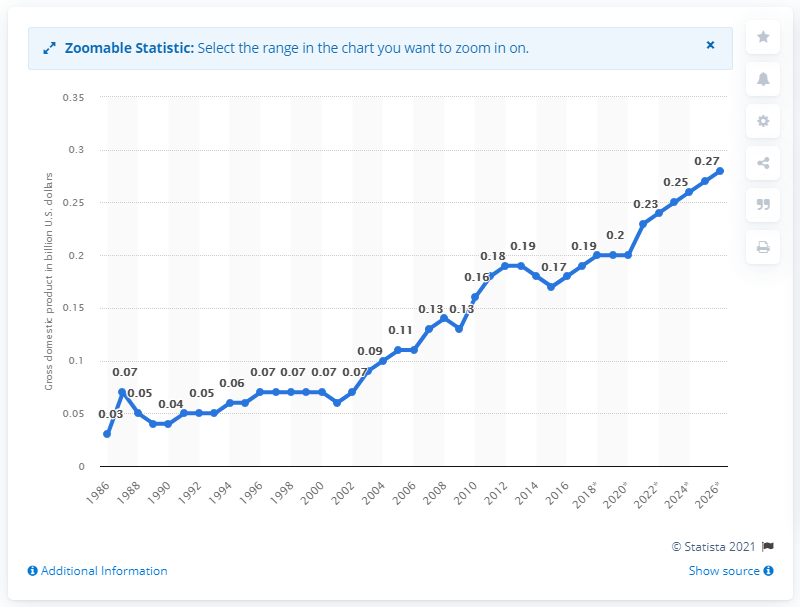List a handful of essential elements in this visual. In 2017, the gross domestic product of Kiribati was approximately 0.19 billion dollars. 